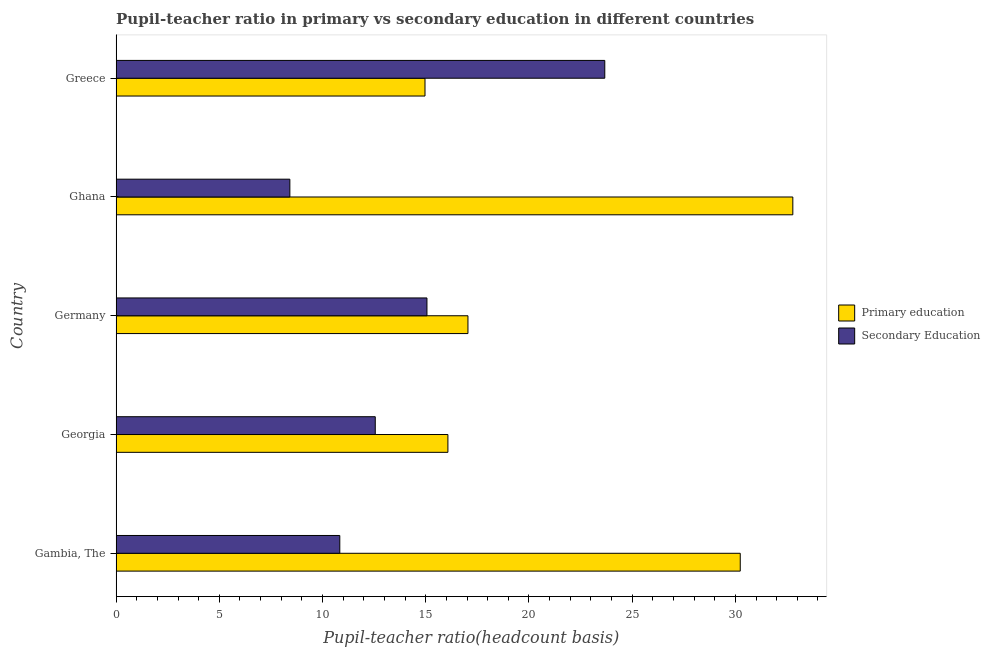How many bars are there on the 1st tick from the bottom?
Ensure brevity in your answer.  2. In how many cases, is the number of bars for a given country not equal to the number of legend labels?
Provide a succinct answer. 0. What is the pupil teacher ratio on secondary education in Georgia?
Your answer should be compact. 12.55. Across all countries, what is the maximum pupil-teacher ratio in primary education?
Offer a terse response. 32.78. Across all countries, what is the minimum pupil-teacher ratio in primary education?
Your answer should be very brief. 14.96. In which country was the pupil-teacher ratio in primary education maximum?
Keep it short and to the point. Ghana. What is the total pupil teacher ratio on secondary education in the graph?
Keep it short and to the point. 70.54. What is the difference between the pupil-teacher ratio in primary education in Ghana and that in Greece?
Your response must be concise. 17.82. What is the difference between the pupil-teacher ratio in primary education in Georgia and the pupil teacher ratio on secondary education in Germany?
Provide a short and direct response. 1.01. What is the average pupil-teacher ratio in primary education per country?
Ensure brevity in your answer.  22.22. What is the difference between the pupil teacher ratio on secondary education and pupil-teacher ratio in primary education in Greece?
Give a very brief answer. 8.71. In how many countries, is the pupil-teacher ratio in primary education greater than 17 ?
Your response must be concise. 3. What is the ratio of the pupil-teacher ratio in primary education in Georgia to that in Germany?
Give a very brief answer. 0.94. Is the pupil-teacher ratio in primary education in Georgia less than that in Germany?
Offer a terse response. Yes. What is the difference between the highest and the second highest pupil-teacher ratio in primary education?
Your response must be concise. 2.55. What is the difference between the highest and the lowest pupil teacher ratio on secondary education?
Make the answer very short. 15.26. In how many countries, is the pupil teacher ratio on secondary education greater than the average pupil teacher ratio on secondary education taken over all countries?
Your answer should be very brief. 2. What does the 2nd bar from the bottom in Gambia, The represents?
Keep it short and to the point. Secondary Education. How many countries are there in the graph?
Provide a succinct answer. 5. Are the values on the major ticks of X-axis written in scientific E-notation?
Provide a short and direct response. No. What is the title of the graph?
Ensure brevity in your answer.  Pupil-teacher ratio in primary vs secondary education in different countries. Does "GDP" appear as one of the legend labels in the graph?
Give a very brief answer. No. What is the label or title of the X-axis?
Offer a very short reply. Pupil-teacher ratio(headcount basis). What is the Pupil-teacher ratio(headcount basis) of Primary education in Gambia, The?
Give a very brief answer. 30.24. What is the Pupil-teacher ratio(headcount basis) of Secondary Education in Gambia, The?
Ensure brevity in your answer.  10.84. What is the Pupil-teacher ratio(headcount basis) of Primary education in Georgia?
Offer a terse response. 16.07. What is the Pupil-teacher ratio(headcount basis) of Secondary Education in Georgia?
Your response must be concise. 12.55. What is the Pupil-teacher ratio(headcount basis) of Primary education in Germany?
Your answer should be compact. 17.04. What is the Pupil-teacher ratio(headcount basis) of Secondary Education in Germany?
Provide a short and direct response. 15.06. What is the Pupil-teacher ratio(headcount basis) in Primary education in Ghana?
Ensure brevity in your answer.  32.78. What is the Pupil-teacher ratio(headcount basis) of Secondary Education in Ghana?
Your answer should be very brief. 8.42. What is the Pupil-teacher ratio(headcount basis) of Primary education in Greece?
Offer a terse response. 14.96. What is the Pupil-teacher ratio(headcount basis) of Secondary Education in Greece?
Offer a terse response. 23.67. Across all countries, what is the maximum Pupil-teacher ratio(headcount basis) of Primary education?
Your answer should be compact. 32.78. Across all countries, what is the maximum Pupil-teacher ratio(headcount basis) in Secondary Education?
Ensure brevity in your answer.  23.67. Across all countries, what is the minimum Pupil-teacher ratio(headcount basis) in Primary education?
Provide a succinct answer. 14.96. Across all countries, what is the minimum Pupil-teacher ratio(headcount basis) in Secondary Education?
Your answer should be very brief. 8.42. What is the total Pupil-teacher ratio(headcount basis) in Primary education in the graph?
Keep it short and to the point. 111.1. What is the total Pupil-teacher ratio(headcount basis) of Secondary Education in the graph?
Offer a terse response. 70.54. What is the difference between the Pupil-teacher ratio(headcount basis) in Primary education in Gambia, The and that in Georgia?
Offer a terse response. 14.16. What is the difference between the Pupil-teacher ratio(headcount basis) in Secondary Education in Gambia, The and that in Georgia?
Your answer should be compact. -1.72. What is the difference between the Pupil-teacher ratio(headcount basis) in Primary education in Gambia, The and that in Germany?
Give a very brief answer. 13.19. What is the difference between the Pupil-teacher ratio(headcount basis) of Secondary Education in Gambia, The and that in Germany?
Make the answer very short. -4.22. What is the difference between the Pupil-teacher ratio(headcount basis) in Primary education in Gambia, The and that in Ghana?
Make the answer very short. -2.55. What is the difference between the Pupil-teacher ratio(headcount basis) in Secondary Education in Gambia, The and that in Ghana?
Your answer should be compact. 2.42. What is the difference between the Pupil-teacher ratio(headcount basis) of Primary education in Gambia, The and that in Greece?
Provide a short and direct response. 15.27. What is the difference between the Pupil-teacher ratio(headcount basis) in Secondary Education in Gambia, The and that in Greece?
Ensure brevity in your answer.  -12.84. What is the difference between the Pupil-teacher ratio(headcount basis) in Primary education in Georgia and that in Germany?
Offer a terse response. -0.97. What is the difference between the Pupil-teacher ratio(headcount basis) in Secondary Education in Georgia and that in Germany?
Keep it short and to the point. -2.5. What is the difference between the Pupil-teacher ratio(headcount basis) of Primary education in Georgia and that in Ghana?
Make the answer very short. -16.71. What is the difference between the Pupil-teacher ratio(headcount basis) of Secondary Education in Georgia and that in Ghana?
Offer a terse response. 4.14. What is the difference between the Pupil-teacher ratio(headcount basis) of Primary education in Georgia and that in Greece?
Give a very brief answer. 1.11. What is the difference between the Pupil-teacher ratio(headcount basis) of Secondary Education in Georgia and that in Greece?
Ensure brevity in your answer.  -11.12. What is the difference between the Pupil-teacher ratio(headcount basis) in Primary education in Germany and that in Ghana?
Offer a terse response. -15.74. What is the difference between the Pupil-teacher ratio(headcount basis) in Secondary Education in Germany and that in Ghana?
Make the answer very short. 6.64. What is the difference between the Pupil-teacher ratio(headcount basis) of Primary education in Germany and that in Greece?
Offer a terse response. 2.08. What is the difference between the Pupil-teacher ratio(headcount basis) in Secondary Education in Germany and that in Greece?
Your answer should be compact. -8.62. What is the difference between the Pupil-teacher ratio(headcount basis) of Primary education in Ghana and that in Greece?
Provide a succinct answer. 17.82. What is the difference between the Pupil-teacher ratio(headcount basis) of Secondary Education in Ghana and that in Greece?
Offer a very short reply. -15.26. What is the difference between the Pupil-teacher ratio(headcount basis) in Primary education in Gambia, The and the Pupil-teacher ratio(headcount basis) in Secondary Education in Georgia?
Your answer should be compact. 17.68. What is the difference between the Pupil-teacher ratio(headcount basis) in Primary education in Gambia, The and the Pupil-teacher ratio(headcount basis) in Secondary Education in Germany?
Your answer should be very brief. 15.18. What is the difference between the Pupil-teacher ratio(headcount basis) in Primary education in Gambia, The and the Pupil-teacher ratio(headcount basis) in Secondary Education in Ghana?
Ensure brevity in your answer.  21.82. What is the difference between the Pupil-teacher ratio(headcount basis) of Primary education in Gambia, The and the Pupil-teacher ratio(headcount basis) of Secondary Education in Greece?
Provide a short and direct response. 6.56. What is the difference between the Pupil-teacher ratio(headcount basis) in Primary education in Georgia and the Pupil-teacher ratio(headcount basis) in Secondary Education in Germany?
Provide a succinct answer. 1.01. What is the difference between the Pupil-teacher ratio(headcount basis) of Primary education in Georgia and the Pupil-teacher ratio(headcount basis) of Secondary Education in Ghana?
Make the answer very short. 7.66. What is the difference between the Pupil-teacher ratio(headcount basis) in Primary education in Georgia and the Pupil-teacher ratio(headcount basis) in Secondary Education in Greece?
Make the answer very short. -7.6. What is the difference between the Pupil-teacher ratio(headcount basis) in Primary education in Germany and the Pupil-teacher ratio(headcount basis) in Secondary Education in Ghana?
Your answer should be very brief. 8.63. What is the difference between the Pupil-teacher ratio(headcount basis) in Primary education in Germany and the Pupil-teacher ratio(headcount basis) in Secondary Education in Greece?
Your answer should be very brief. -6.63. What is the difference between the Pupil-teacher ratio(headcount basis) in Primary education in Ghana and the Pupil-teacher ratio(headcount basis) in Secondary Education in Greece?
Your answer should be very brief. 9.11. What is the average Pupil-teacher ratio(headcount basis) in Primary education per country?
Provide a short and direct response. 22.22. What is the average Pupil-teacher ratio(headcount basis) of Secondary Education per country?
Give a very brief answer. 14.11. What is the difference between the Pupil-teacher ratio(headcount basis) of Primary education and Pupil-teacher ratio(headcount basis) of Secondary Education in Gambia, The?
Your answer should be very brief. 19.4. What is the difference between the Pupil-teacher ratio(headcount basis) in Primary education and Pupil-teacher ratio(headcount basis) in Secondary Education in Georgia?
Your answer should be very brief. 3.52. What is the difference between the Pupil-teacher ratio(headcount basis) of Primary education and Pupil-teacher ratio(headcount basis) of Secondary Education in Germany?
Provide a short and direct response. 1.99. What is the difference between the Pupil-teacher ratio(headcount basis) in Primary education and Pupil-teacher ratio(headcount basis) in Secondary Education in Ghana?
Keep it short and to the point. 24.37. What is the difference between the Pupil-teacher ratio(headcount basis) in Primary education and Pupil-teacher ratio(headcount basis) in Secondary Education in Greece?
Offer a terse response. -8.71. What is the ratio of the Pupil-teacher ratio(headcount basis) of Primary education in Gambia, The to that in Georgia?
Provide a succinct answer. 1.88. What is the ratio of the Pupil-teacher ratio(headcount basis) in Secondary Education in Gambia, The to that in Georgia?
Make the answer very short. 0.86. What is the ratio of the Pupil-teacher ratio(headcount basis) in Primary education in Gambia, The to that in Germany?
Offer a very short reply. 1.77. What is the ratio of the Pupil-teacher ratio(headcount basis) in Secondary Education in Gambia, The to that in Germany?
Keep it short and to the point. 0.72. What is the ratio of the Pupil-teacher ratio(headcount basis) of Primary education in Gambia, The to that in Ghana?
Keep it short and to the point. 0.92. What is the ratio of the Pupil-teacher ratio(headcount basis) of Secondary Education in Gambia, The to that in Ghana?
Give a very brief answer. 1.29. What is the ratio of the Pupil-teacher ratio(headcount basis) of Primary education in Gambia, The to that in Greece?
Provide a short and direct response. 2.02. What is the ratio of the Pupil-teacher ratio(headcount basis) in Secondary Education in Gambia, The to that in Greece?
Offer a very short reply. 0.46. What is the ratio of the Pupil-teacher ratio(headcount basis) in Primary education in Georgia to that in Germany?
Offer a terse response. 0.94. What is the ratio of the Pupil-teacher ratio(headcount basis) in Secondary Education in Georgia to that in Germany?
Provide a short and direct response. 0.83. What is the ratio of the Pupil-teacher ratio(headcount basis) in Primary education in Georgia to that in Ghana?
Provide a succinct answer. 0.49. What is the ratio of the Pupil-teacher ratio(headcount basis) in Secondary Education in Georgia to that in Ghana?
Provide a succinct answer. 1.49. What is the ratio of the Pupil-teacher ratio(headcount basis) of Primary education in Georgia to that in Greece?
Offer a very short reply. 1.07. What is the ratio of the Pupil-teacher ratio(headcount basis) of Secondary Education in Georgia to that in Greece?
Ensure brevity in your answer.  0.53. What is the ratio of the Pupil-teacher ratio(headcount basis) in Primary education in Germany to that in Ghana?
Offer a terse response. 0.52. What is the ratio of the Pupil-teacher ratio(headcount basis) in Secondary Education in Germany to that in Ghana?
Offer a very short reply. 1.79. What is the ratio of the Pupil-teacher ratio(headcount basis) in Primary education in Germany to that in Greece?
Provide a short and direct response. 1.14. What is the ratio of the Pupil-teacher ratio(headcount basis) in Secondary Education in Germany to that in Greece?
Your answer should be very brief. 0.64. What is the ratio of the Pupil-teacher ratio(headcount basis) in Primary education in Ghana to that in Greece?
Provide a short and direct response. 2.19. What is the ratio of the Pupil-teacher ratio(headcount basis) of Secondary Education in Ghana to that in Greece?
Your answer should be compact. 0.36. What is the difference between the highest and the second highest Pupil-teacher ratio(headcount basis) of Primary education?
Your response must be concise. 2.55. What is the difference between the highest and the second highest Pupil-teacher ratio(headcount basis) in Secondary Education?
Your response must be concise. 8.62. What is the difference between the highest and the lowest Pupil-teacher ratio(headcount basis) of Primary education?
Your response must be concise. 17.82. What is the difference between the highest and the lowest Pupil-teacher ratio(headcount basis) in Secondary Education?
Keep it short and to the point. 15.26. 